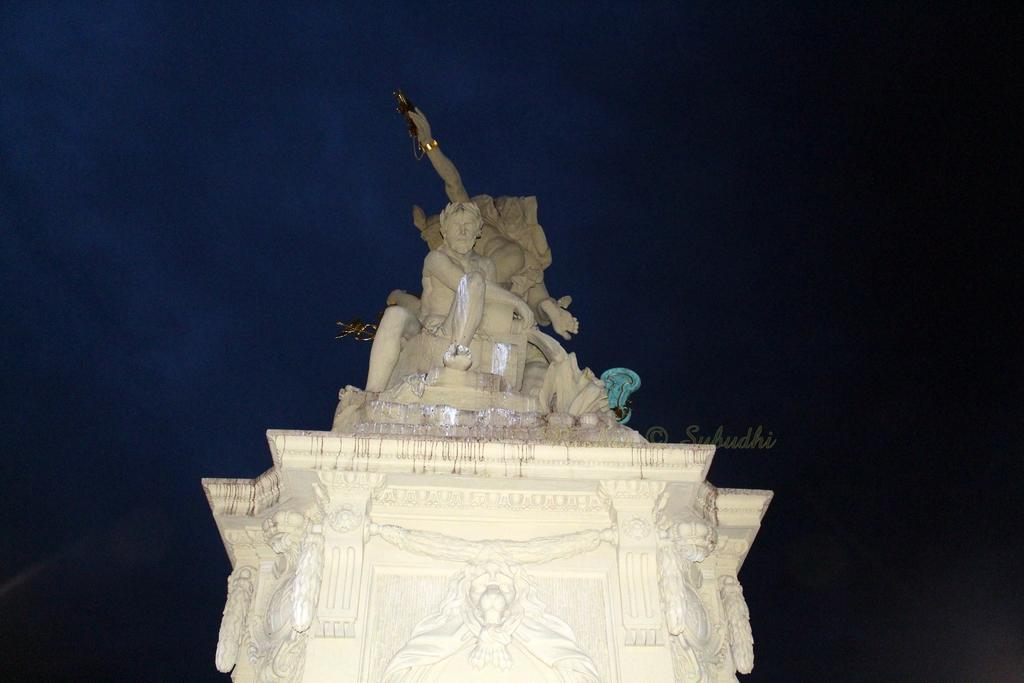What can be seen in the picture? There are statues in the picture. What is supporting the statues? There is a pillar below the statues. What is unique about the pillar? The pillar is carved with different structures. What type of plants can be seen growing around the statues in the image? There are no plants visible in the image; it only features statues and a carved pillar. 